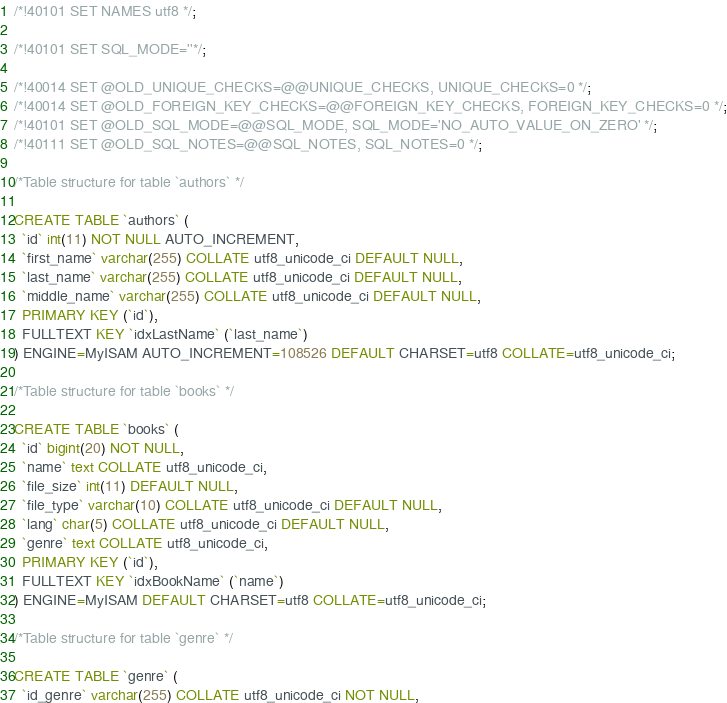<code> <loc_0><loc_0><loc_500><loc_500><_SQL_>/*!40101 SET NAMES utf8 */;

/*!40101 SET SQL_MODE=''*/;

/*!40014 SET @OLD_UNIQUE_CHECKS=@@UNIQUE_CHECKS, UNIQUE_CHECKS=0 */;
/*!40014 SET @OLD_FOREIGN_KEY_CHECKS=@@FOREIGN_KEY_CHECKS, FOREIGN_KEY_CHECKS=0 */;
/*!40101 SET @OLD_SQL_MODE=@@SQL_MODE, SQL_MODE='NO_AUTO_VALUE_ON_ZERO' */;
/*!40111 SET @OLD_SQL_NOTES=@@SQL_NOTES, SQL_NOTES=0 */;

/*Table structure for table `authors` */

CREATE TABLE `authors` (
  `id` int(11) NOT NULL AUTO_INCREMENT,
  `first_name` varchar(255) COLLATE utf8_unicode_ci DEFAULT NULL,
  `last_name` varchar(255) COLLATE utf8_unicode_ci DEFAULT NULL,
  `middle_name` varchar(255) COLLATE utf8_unicode_ci DEFAULT NULL,
  PRIMARY KEY (`id`),
  FULLTEXT KEY `idxLastName` (`last_name`)
) ENGINE=MyISAM AUTO_INCREMENT=108526 DEFAULT CHARSET=utf8 COLLATE=utf8_unicode_ci;

/*Table structure for table `books` */

CREATE TABLE `books` (
  `id` bigint(20) NOT NULL,
  `name` text COLLATE utf8_unicode_ci,
  `file_size` int(11) DEFAULT NULL,
  `file_type` varchar(10) COLLATE utf8_unicode_ci DEFAULT NULL,
  `lang` char(5) COLLATE utf8_unicode_ci DEFAULT NULL,
  `genre` text COLLATE utf8_unicode_ci,
  PRIMARY KEY (`id`),
  FULLTEXT KEY `idxBookName` (`name`)
) ENGINE=MyISAM DEFAULT CHARSET=utf8 COLLATE=utf8_unicode_ci;

/*Table structure for table `genre` */

CREATE TABLE `genre` (
  `id_genre` varchar(255) COLLATE utf8_unicode_ci NOT NULL,</code> 